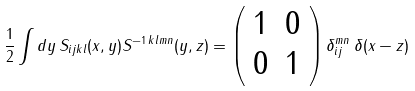<formula> <loc_0><loc_0><loc_500><loc_500>\frac { 1 } { 2 } \int d y \, S _ { i j k l } ( x , y ) S ^ { - 1 \, k l m n } ( y , z ) = \left ( \begin{array} { c c } { 1 } & { 0 } \\ { 0 } & { 1 } \end{array} \right ) \delta _ { i j } ^ { m n } \, \delta ( x - z )</formula> 